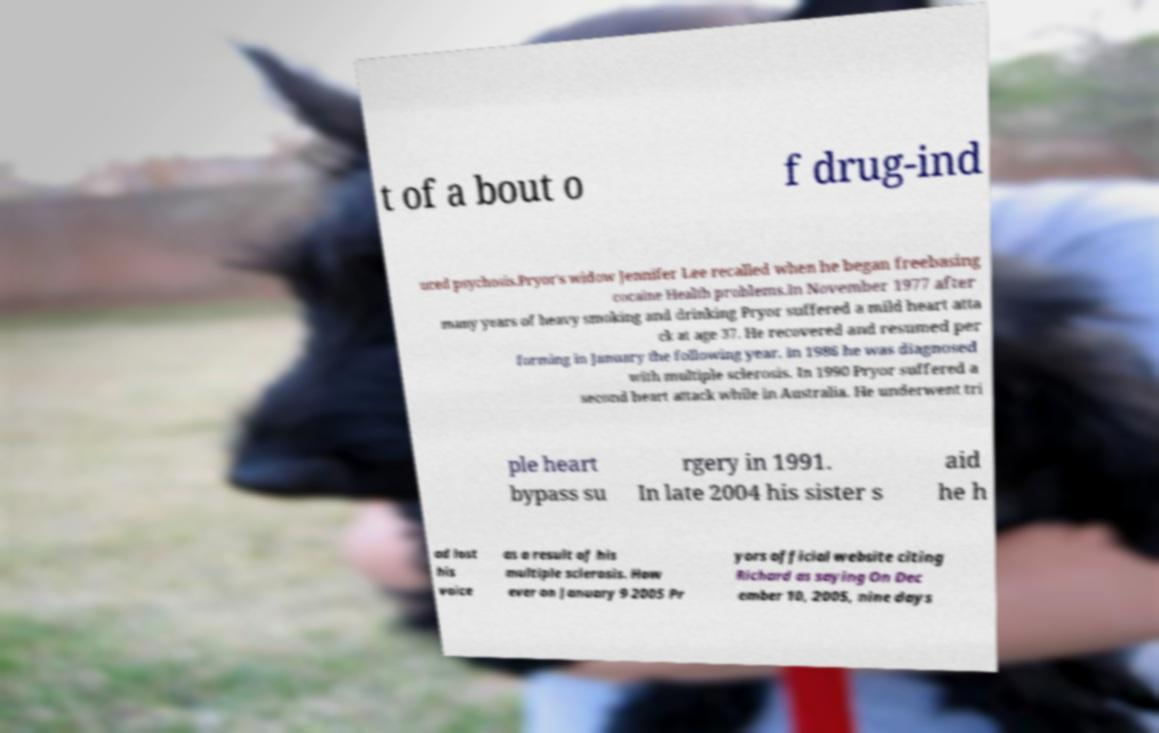For documentation purposes, I need the text within this image transcribed. Could you provide that? t of a bout o f drug-ind uced psychosis.Pryor's widow Jennifer Lee recalled when he began freebasing cocaine Health problems.In November 1977 after many years of heavy smoking and drinking Pryor suffered a mild heart atta ck at age 37. He recovered and resumed per forming in January the following year. In 1986 he was diagnosed with multiple sclerosis. In 1990 Pryor suffered a second heart attack while in Australia. He underwent tri ple heart bypass su rgery in 1991. In late 2004 his sister s aid he h ad lost his voice as a result of his multiple sclerosis. How ever on January 9 2005 Pr yors official website citing Richard as saying On Dec ember 10, 2005, nine days 